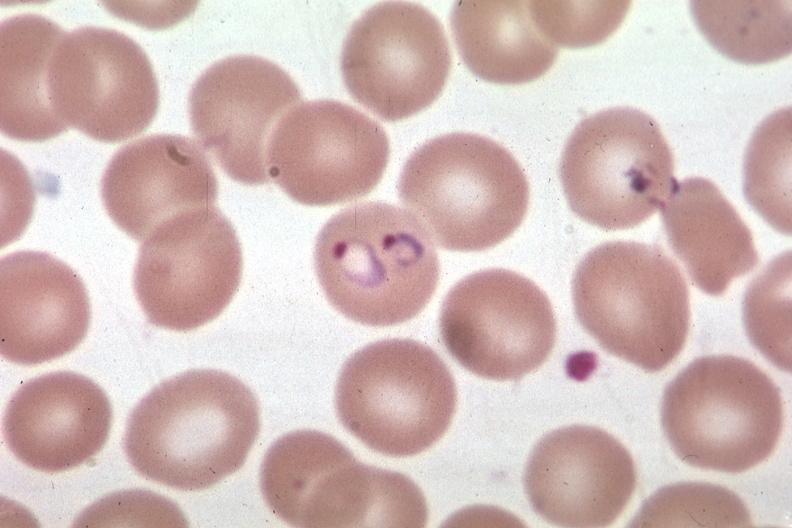s hematologic present?
Answer the question using a single word or phrase. Yes 